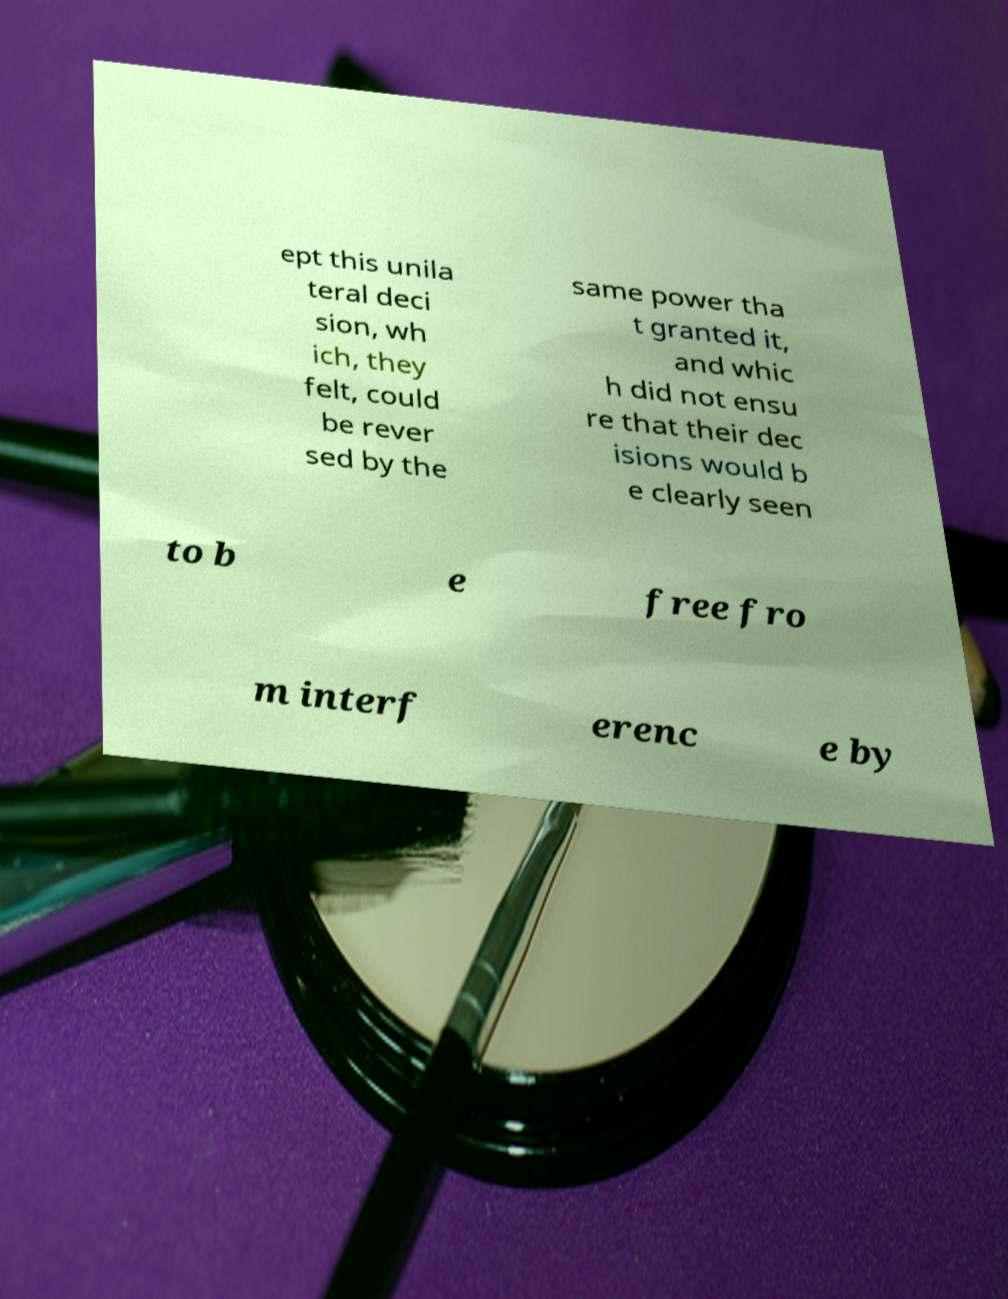I need the written content from this picture converted into text. Can you do that? ept this unila teral deci sion, wh ich, they felt, could be rever sed by the same power tha t granted it, and whic h did not ensu re that their dec isions would b e clearly seen to b e free fro m interf erenc e by 